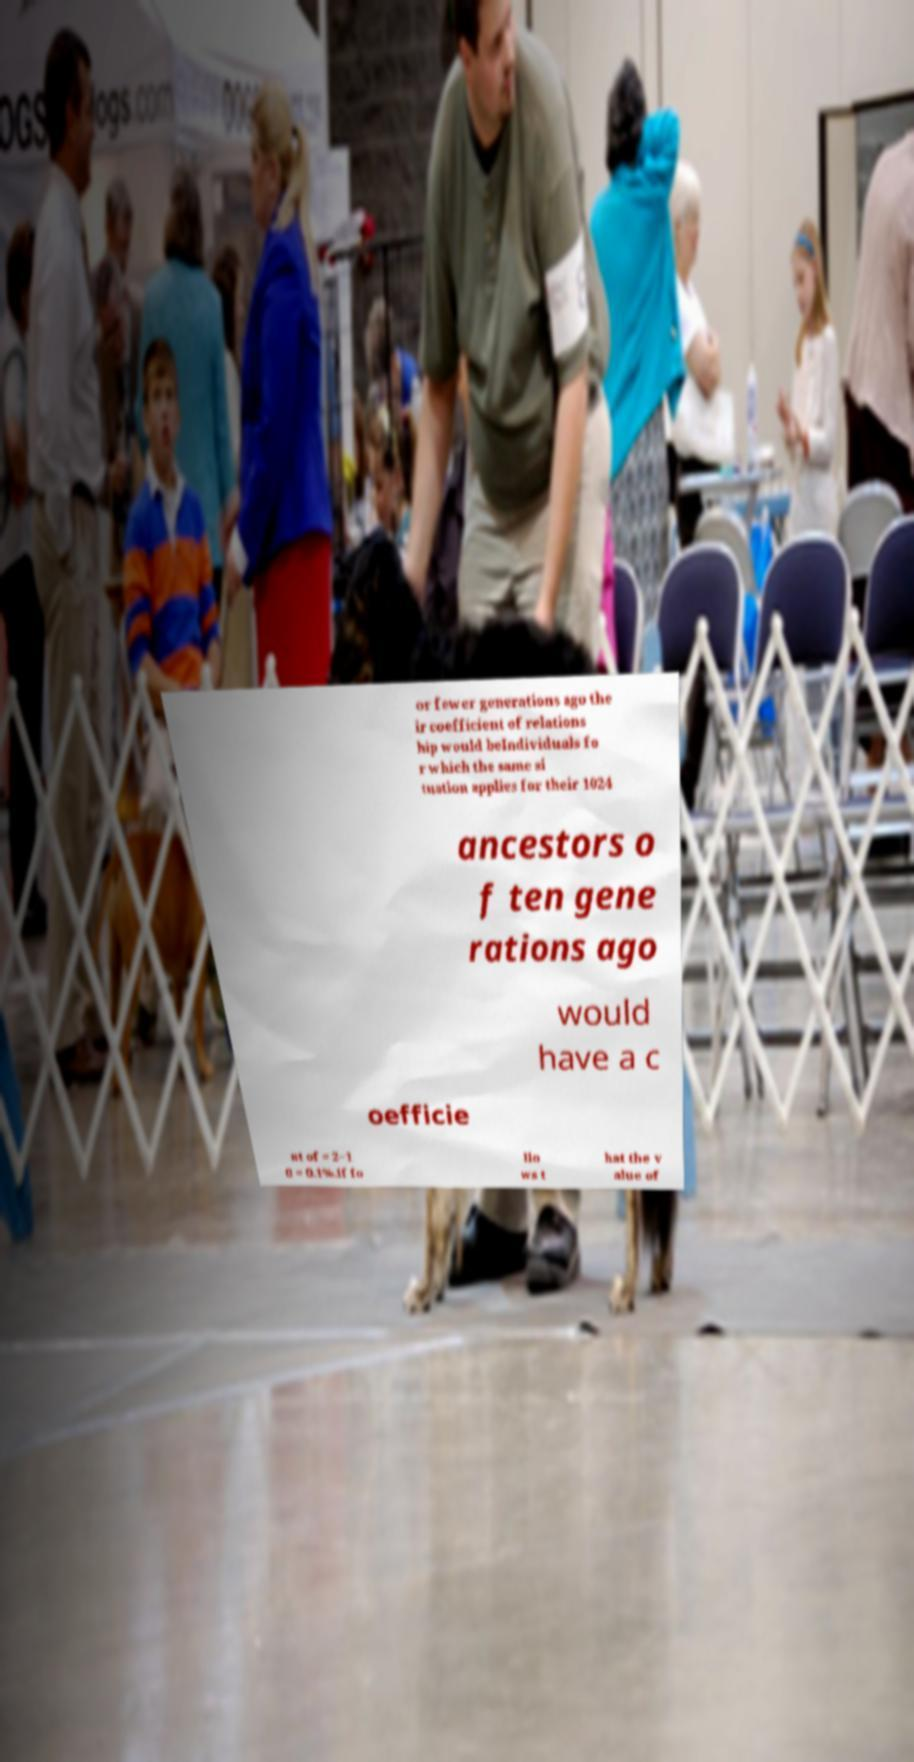Can you accurately transcribe the text from the provided image for me? or fewer generations ago the ir coefficient of relations hip would beIndividuals fo r which the same si tuation applies for their 1024 ancestors o f ten gene rations ago would have a c oefficie nt of = 2−1 0 = 0.1%.If fo llo ws t hat the v alue of 